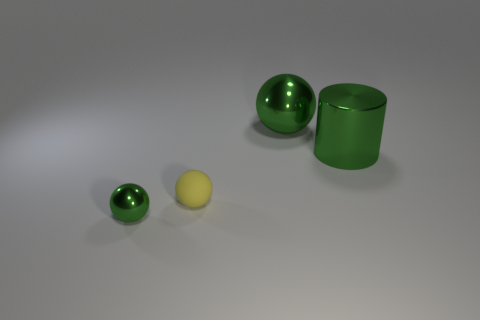What number of other objects are there of the same color as the cylinder?
Your response must be concise. 2. There is a green metal thing that is to the right of the big green ball; is it the same shape as the tiny green shiny object?
Your response must be concise. No. There is another tiny thing that is the same shape as the small yellow matte object; what is its color?
Give a very brief answer. Green. What number of large green things have the same shape as the yellow rubber object?
Keep it short and to the point. 1. How many things are large blue cylinders or objects that are in front of the big sphere?
Provide a succinct answer. 3. Do the large sphere and the thing that is in front of the yellow thing have the same color?
Your response must be concise. Yes. What is the size of the sphere that is on the right side of the small green metallic sphere and in front of the shiny cylinder?
Your answer should be very brief. Small. Are there any green metallic cylinders left of the yellow matte object?
Make the answer very short. No. There is a green shiny ball behind the green metallic cylinder; is there a large green object that is on the right side of it?
Give a very brief answer. Yes. Are there the same number of big green objects on the right side of the big metallic cylinder and yellow matte spheres that are in front of the tiny yellow thing?
Give a very brief answer. Yes. 